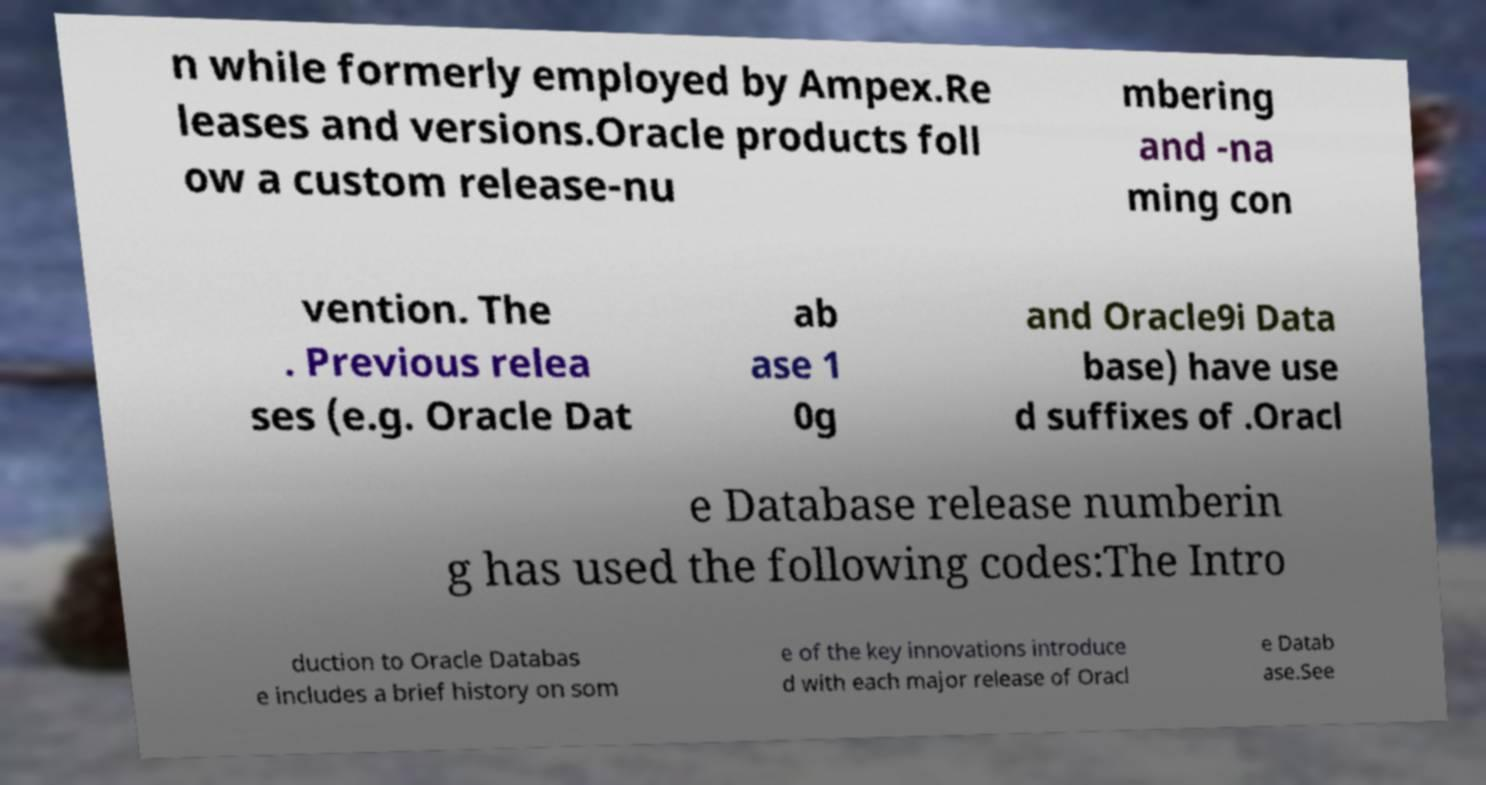Please identify and transcribe the text found in this image. n while formerly employed by Ampex.Re leases and versions.Oracle products foll ow a custom release-nu mbering and -na ming con vention. The . Previous relea ses (e.g. Oracle Dat ab ase 1 0g and Oracle9i Data base) have use d suffixes of .Oracl e Database release numberin g has used the following codes:The Intro duction to Oracle Databas e includes a brief history on som e of the key innovations introduce d with each major release of Oracl e Datab ase.See 